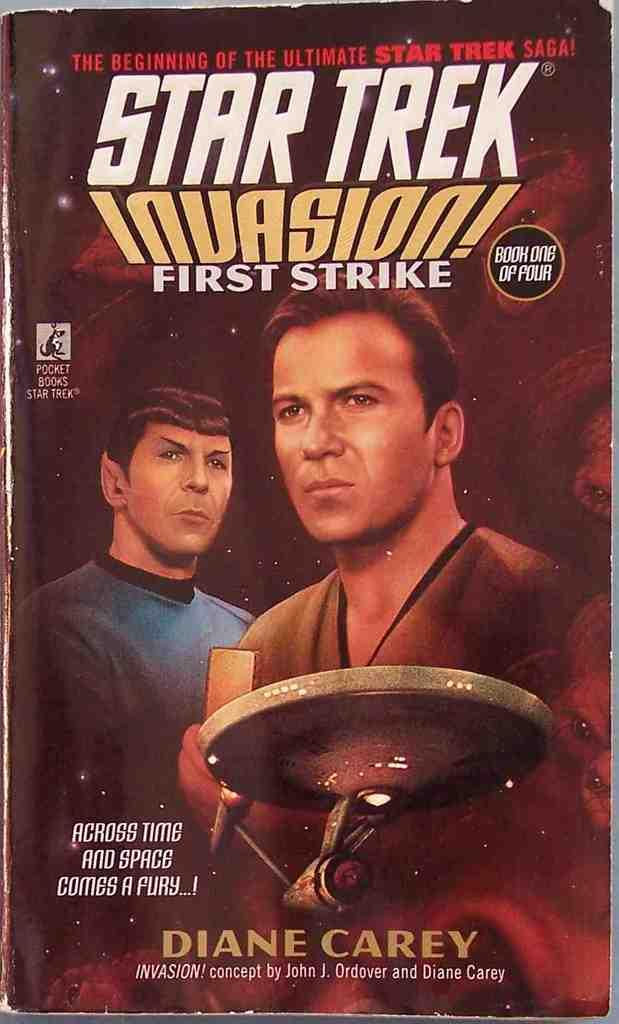<image>
Give a short and clear explanation of the subsequent image. The front cover a Star Trek Invasion First Strike book. 